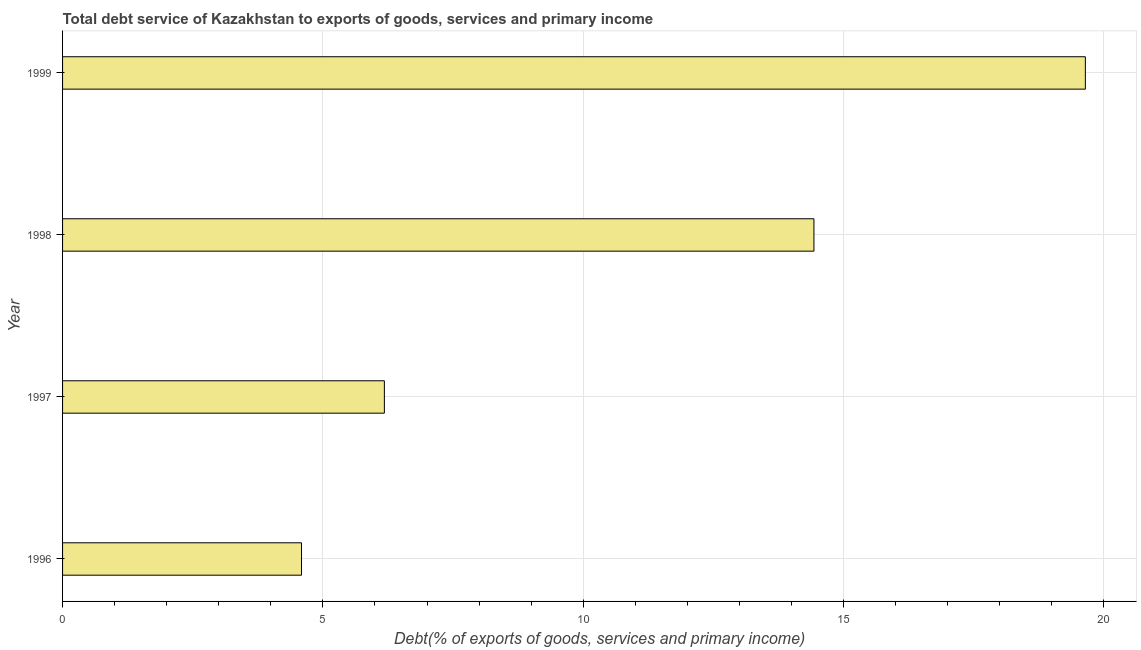Does the graph contain any zero values?
Offer a very short reply. No. What is the title of the graph?
Ensure brevity in your answer.  Total debt service of Kazakhstan to exports of goods, services and primary income. What is the label or title of the X-axis?
Provide a succinct answer. Debt(% of exports of goods, services and primary income). What is the total debt service in 1996?
Offer a very short reply. 4.59. Across all years, what is the maximum total debt service?
Your answer should be compact. 19.64. Across all years, what is the minimum total debt service?
Your answer should be very brief. 4.59. In which year was the total debt service maximum?
Your response must be concise. 1999. In which year was the total debt service minimum?
Your answer should be very brief. 1996. What is the sum of the total debt service?
Provide a succinct answer. 44.85. What is the difference between the total debt service in 1997 and 1999?
Ensure brevity in your answer.  -13.46. What is the average total debt service per year?
Offer a terse response. 11.21. What is the median total debt service?
Offer a terse response. 10.31. In how many years, is the total debt service greater than 2 %?
Offer a very short reply. 4. Do a majority of the years between 1997 and 1996 (inclusive) have total debt service greater than 6 %?
Provide a succinct answer. No. What is the ratio of the total debt service in 1997 to that in 1999?
Ensure brevity in your answer.  0.32. Is the total debt service in 1997 less than that in 1999?
Give a very brief answer. Yes. Is the difference between the total debt service in 1996 and 1997 greater than the difference between any two years?
Give a very brief answer. No. What is the difference between the highest and the second highest total debt service?
Your answer should be very brief. 5.21. What is the difference between the highest and the lowest total debt service?
Provide a short and direct response. 15.05. In how many years, is the total debt service greater than the average total debt service taken over all years?
Provide a succinct answer. 2. How many years are there in the graph?
Offer a very short reply. 4. Are the values on the major ticks of X-axis written in scientific E-notation?
Provide a succinct answer. No. What is the Debt(% of exports of goods, services and primary income) of 1996?
Provide a succinct answer. 4.59. What is the Debt(% of exports of goods, services and primary income) in 1997?
Make the answer very short. 6.18. What is the Debt(% of exports of goods, services and primary income) in 1998?
Offer a very short reply. 14.43. What is the Debt(% of exports of goods, services and primary income) of 1999?
Your response must be concise. 19.64. What is the difference between the Debt(% of exports of goods, services and primary income) in 1996 and 1997?
Your answer should be very brief. -1.59. What is the difference between the Debt(% of exports of goods, services and primary income) in 1996 and 1998?
Your answer should be compact. -9.84. What is the difference between the Debt(% of exports of goods, services and primary income) in 1996 and 1999?
Your answer should be compact. -15.05. What is the difference between the Debt(% of exports of goods, services and primary income) in 1997 and 1998?
Offer a very short reply. -8.25. What is the difference between the Debt(% of exports of goods, services and primary income) in 1997 and 1999?
Your answer should be compact. -13.46. What is the difference between the Debt(% of exports of goods, services and primary income) in 1998 and 1999?
Your answer should be compact. -5.21. What is the ratio of the Debt(% of exports of goods, services and primary income) in 1996 to that in 1997?
Your answer should be compact. 0.74. What is the ratio of the Debt(% of exports of goods, services and primary income) in 1996 to that in 1998?
Give a very brief answer. 0.32. What is the ratio of the Debt(% of exports of goods, services and primary income) in 1996 to that in 1999?
Offer a terse response. 0.23. What is the ratio of the Debt(% of exports of goods, services and primary income) in 1997 to that in 1998?
Your answer should be compact. 0.43. What is the ratio of the Debt(% of exports of goods, services and primary income) in 1997 to that in 1999?
Ensure brevity in your answer.  0.32. What is the ratio of the Debt(% of exports of goods, services and primary income) in 1998 to that in 1999?
Make the answer very short. 0.73. 